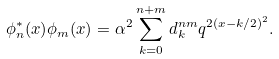<formula> <loc_0><loc_0><loc_500><loc_500>\phi _ { n } ^ { * } ( x ) \phi _ { m } ( x ) = \alpha ^ { 2 } \sum _ { k = 0 } ^ { n + m } d _ { k } ^ { n m } q ^ { 2 ( x - k / 2 ) ^ { 2 } } .</formula> 